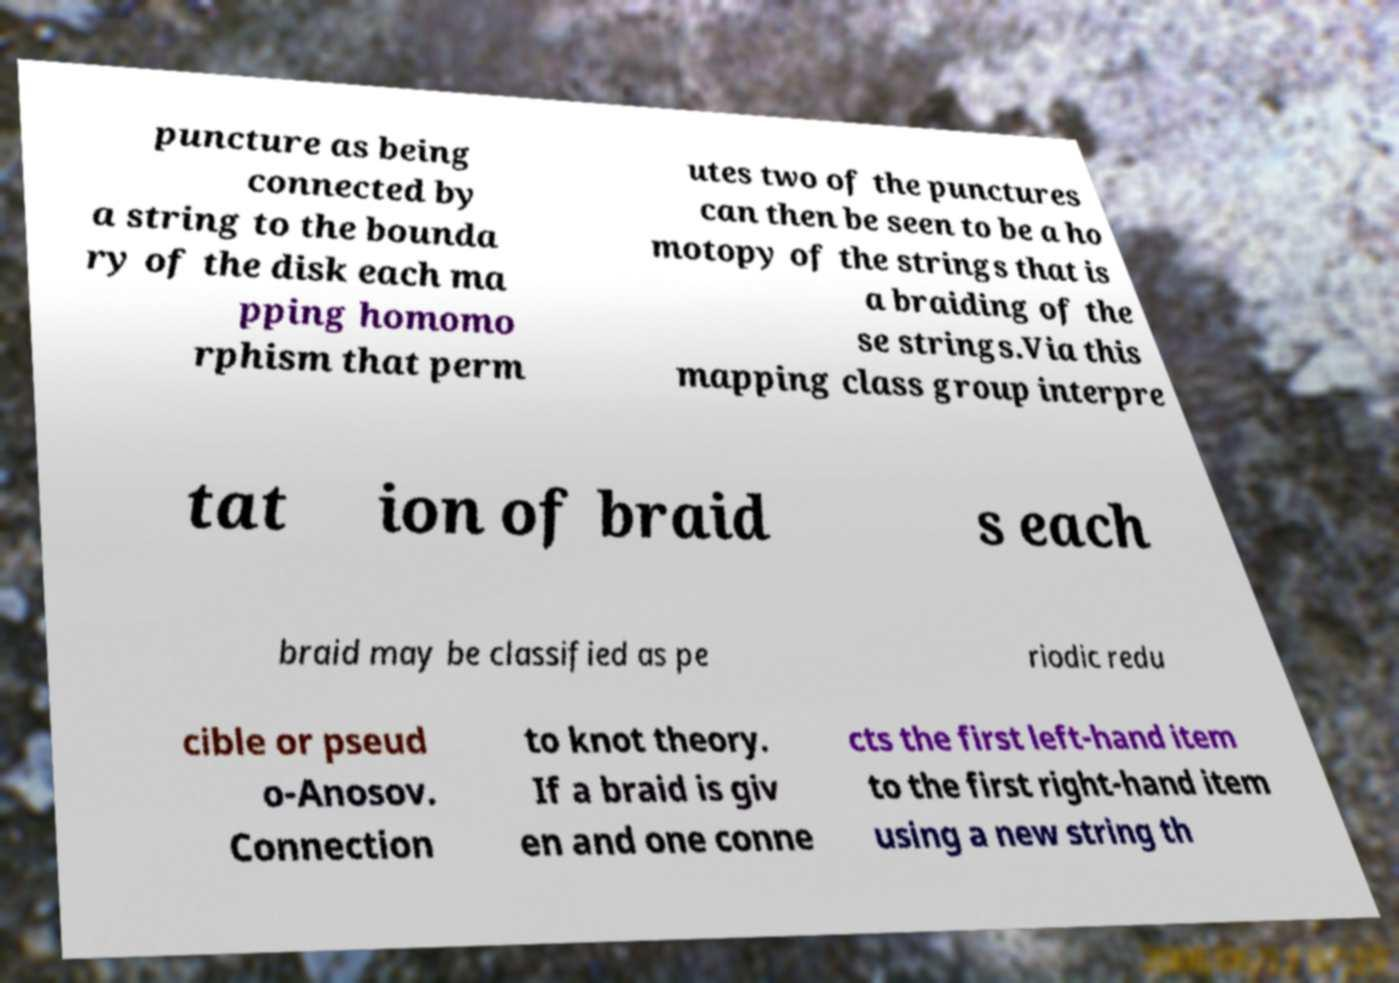Can you read and provide the text displayed in the image?This photo seems to have some interesting text. Can you extract and type it out for me? puncture as being connected by a string to the bounda ry of the disk each ma pping homomo rphism that perm utes two of the punctures can then be seen to be a ho motopy of the strings that is a braiding of the se strings.Via this mapping class group interpre tat ion of braid s each braid may be classified as pe riodic redu cible or pseud o-Anosov. Connection to knot theory. If a braid is giv en and one conne cts the first left-hand item to the first right-hand item using a new string th 